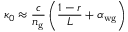Convert formula to latex. <formula><loc_0><loc_0><loc_500><loc_500>\kappa _ { 0 } \approx \frac { c } { n _ { g } } \left ( \frac { 1 - r } { L } + \alpha _ { w g } \right )</formula> 